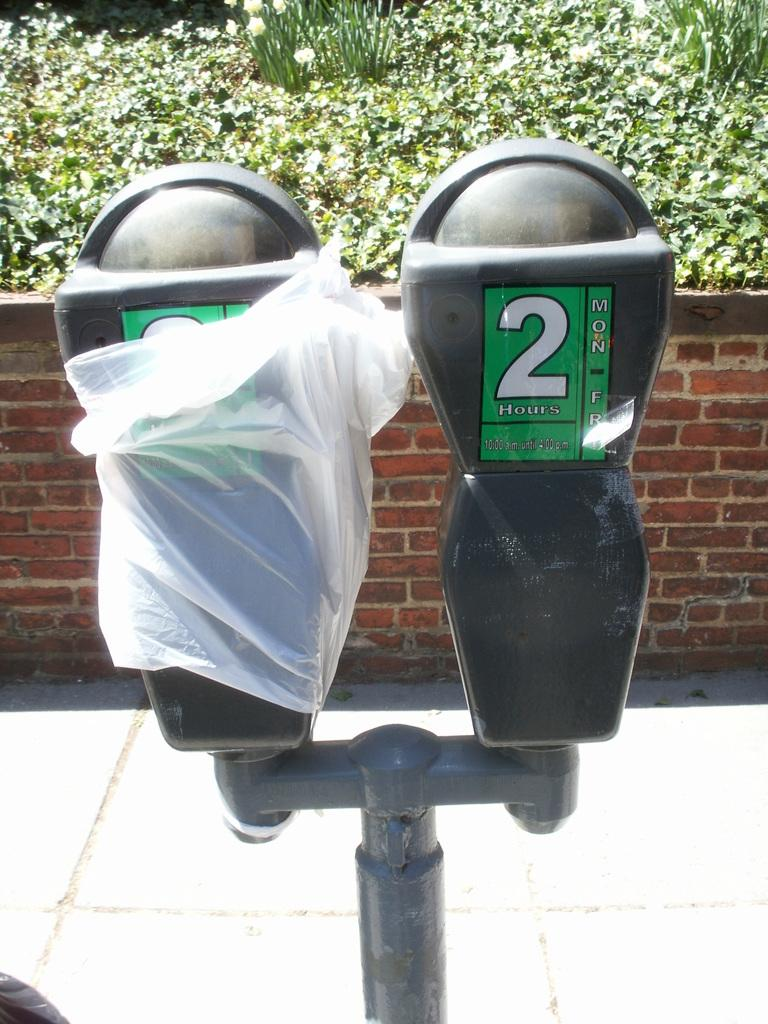<image>
Create a compact narrative representing the image presented. a parking meter with one side covered in plastic wrap and the other side labeled 2 